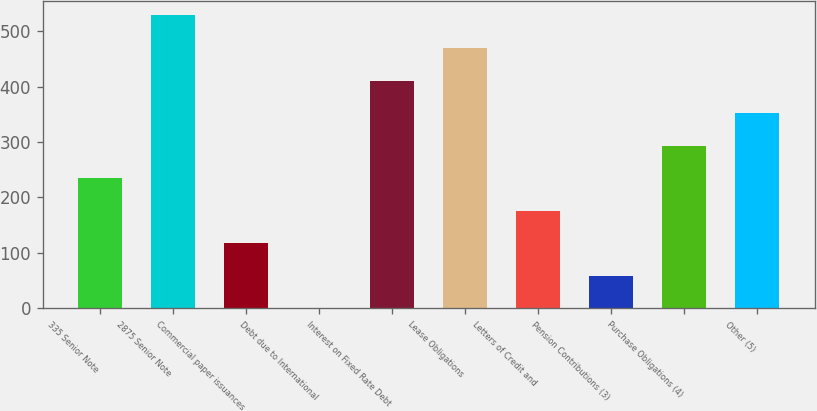Convert chart to OTSL. <chart><loc_0><loc_0><loc_500><loc_500><bar_chart><fcel>335 Senior Note<fcel>2875 Senior Note<fcel>Commercial paper issuances<fcel>Debt due to International<fcel>Interest on Fixed Rate Debt<fcel>Lease Obligations<fcel>Letters of Credit and<fcel>Pension Contributions (3)<fcel>Purchase Obligations (4)<fcel>Other (5)<nl><fcel>235.02<fcel>528.37<fcel>117.68<fcel>0.34<fcel>411.03<fcel>469.7<fcel>176.35<fcel>59.01<fcel>293.69<fcel>352.36<nl></chart> 